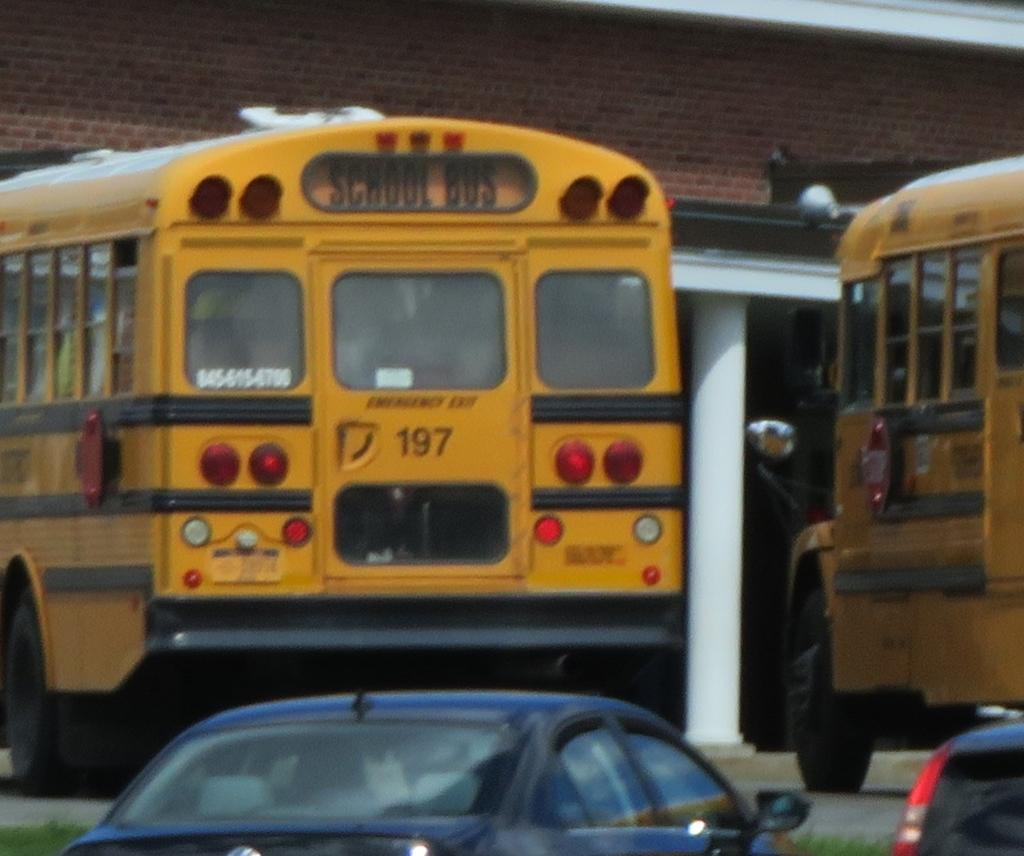How many buses are in the image? There are two buses in the image. What other type of vehicle is present in the image? There is another vehicle in the image, making a total of two vehicles. What type of natural environment can be seen in the image? There is grass visible in the image. What type of man-made structure is present in the image? There is a building in the image. What type of button can be seen on the hospital in the image? There is no hospital or button present in the image. How many feet are visible in the image? There are no feet visible in the image. 